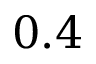Convert formula to latex. <formula><loc_0><loc_0><loc_500><loc_500>0 . 4</formula> 